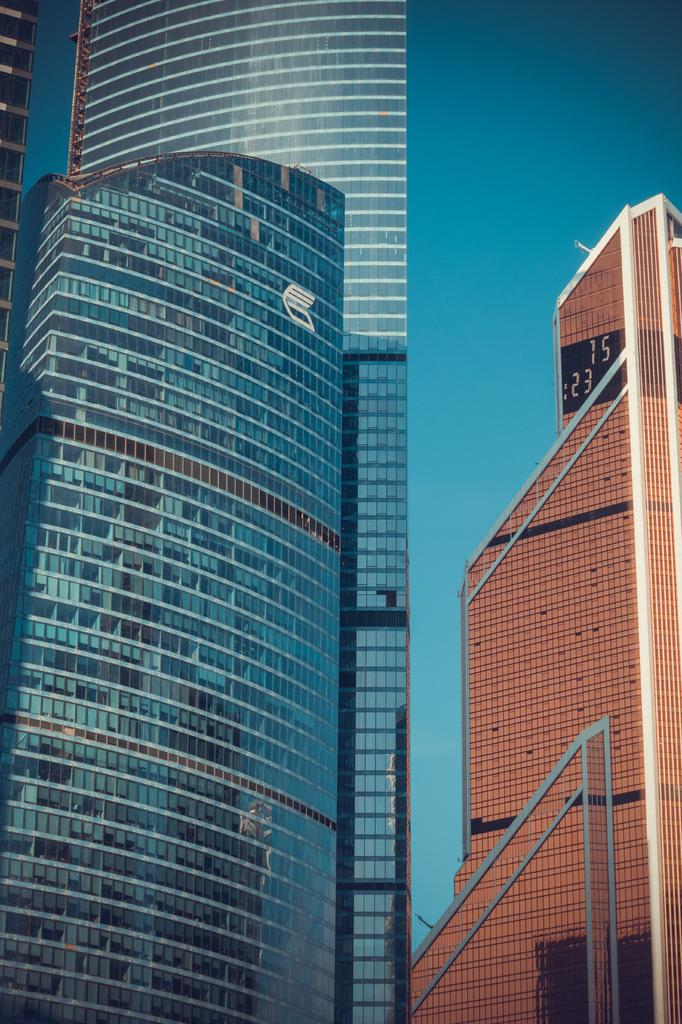What type of material is used for the buildings on the left side of the image? The buildings on the left side of the image have glass. What feature can be seen on the building on the right side of the image? There is a building with a screen on the right side of the image. What can be seen in the background of the image? The sky is visible in the background of the image. What type of stone is used to build the addition on the left side of the image? There is no addition mentioned in the image, and no stone is visible. 